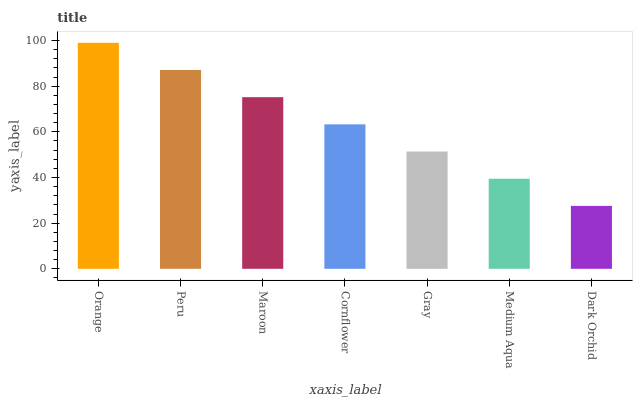Is Dark Orchid the minimum?
Answer yes or no. Yes. Is Orange the maximum?
Answer yes or no. Yes. Is Peru the minimum?
Answer yes or no. No. Is Peru the maximum?
Answer yes or no. No. Is Orange greater than Peru?
Answer yes or no. Yes. Is Peru less than Orange?
Answer yes or no. Yes. Is Peru greater than Orange?
Answer yes or no. No. Is Orange less than Peru?
Answer yes or no. No. Is Cornflower the high median?
Answer yes or no. Yes. Is Cornflower the low median?
Answer yes or no. Yes. Is Maroon the high median?
Answer yes or no. No. Is Peru the low median?
Answer yes or no. No. 